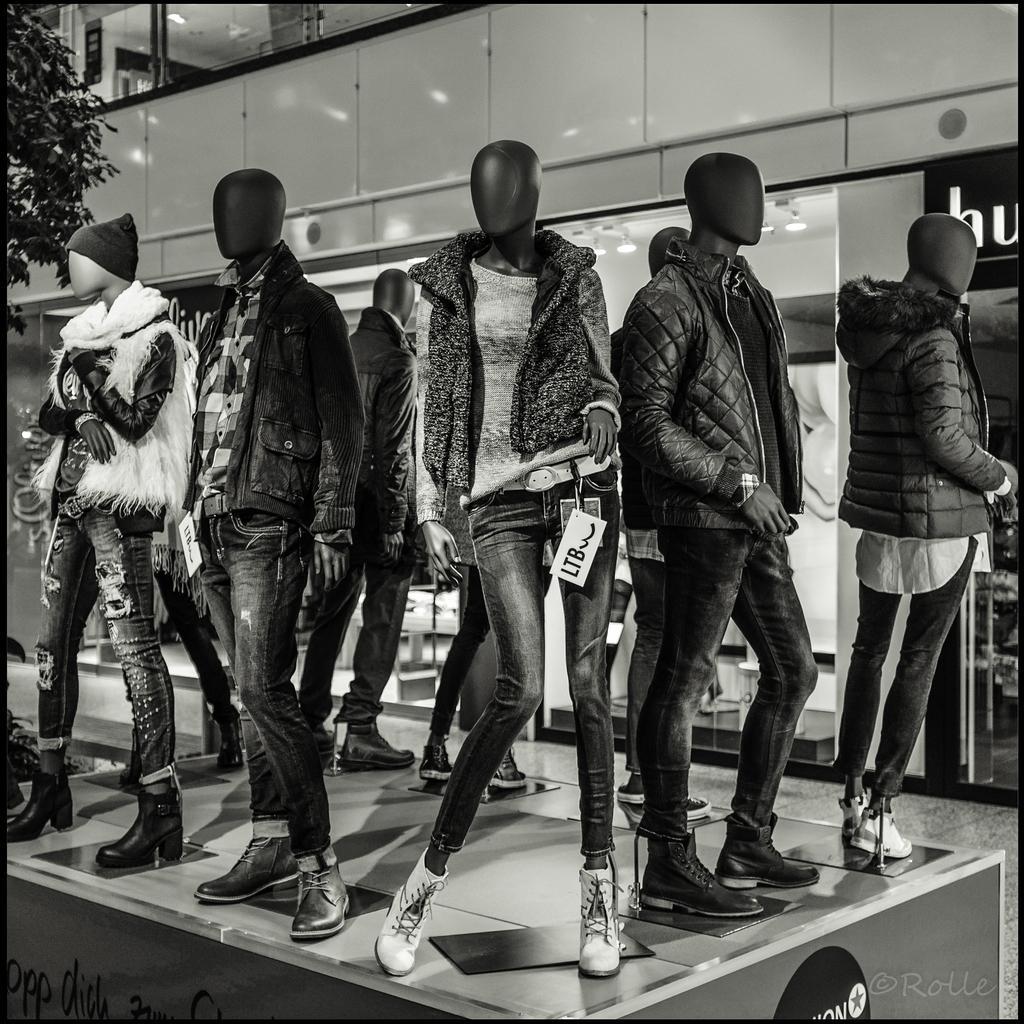Could you give a brief overview of what you see in this image? In the picture we can see some mannequins with different type of jackets and beside it we can see a part of plant and behind it we can see a building wall with glass to it. 